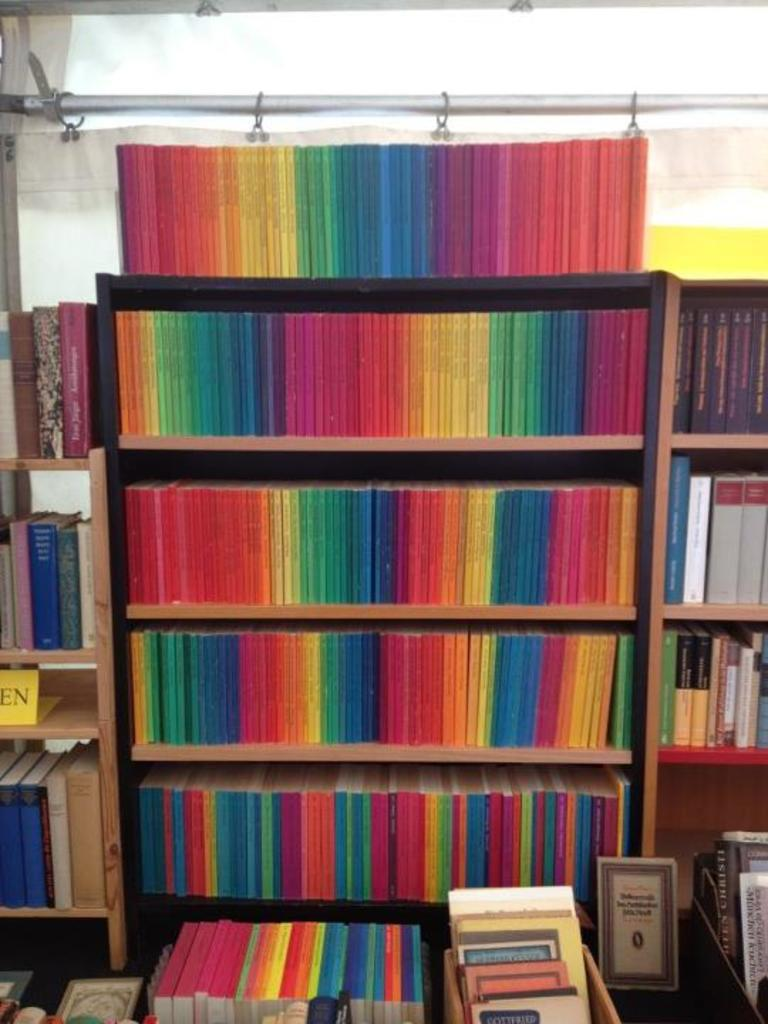What type of items can be seen in the image? There are books and a board in the image. Where are the books and board located? The books and board are in wooden racks. What else can be seen on the wooden racks? There are objects on a platform in the wooden racks. What is visible in the background of the image? There is a curtain and a rod associated with the curtain in the background of the image. How many buns are present on the platform in the image? There is no mention of buns in the image; the objects on the platform are not specified. 